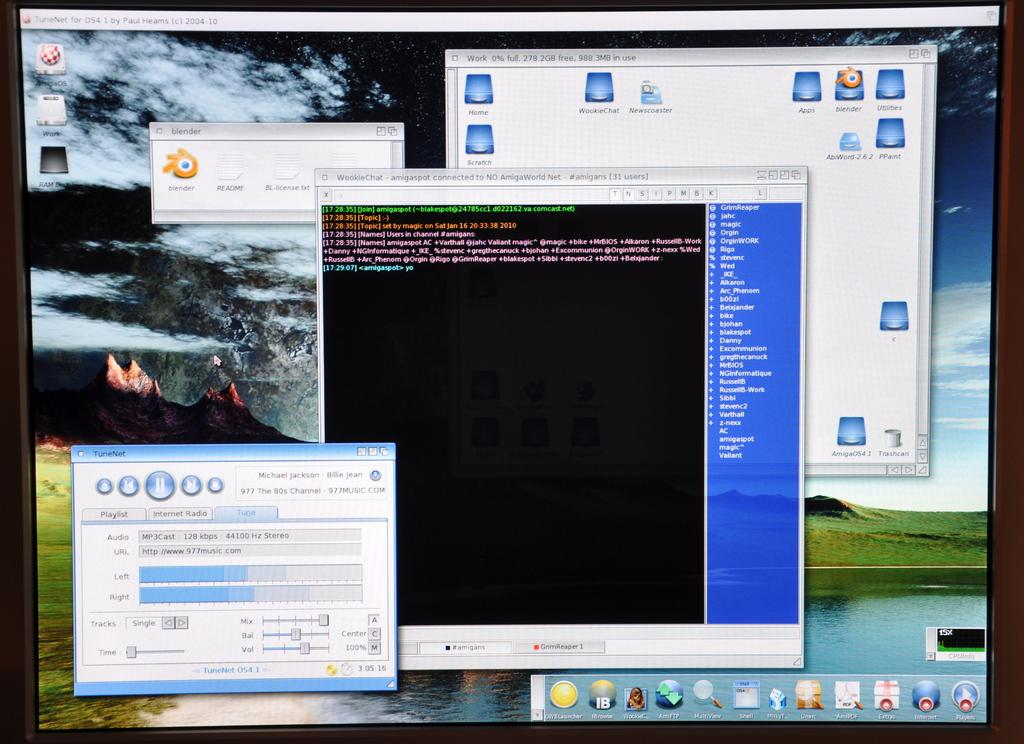Provide a one-sentence caption for the provided image. A computer screen shows that the TuneNet program is open. 